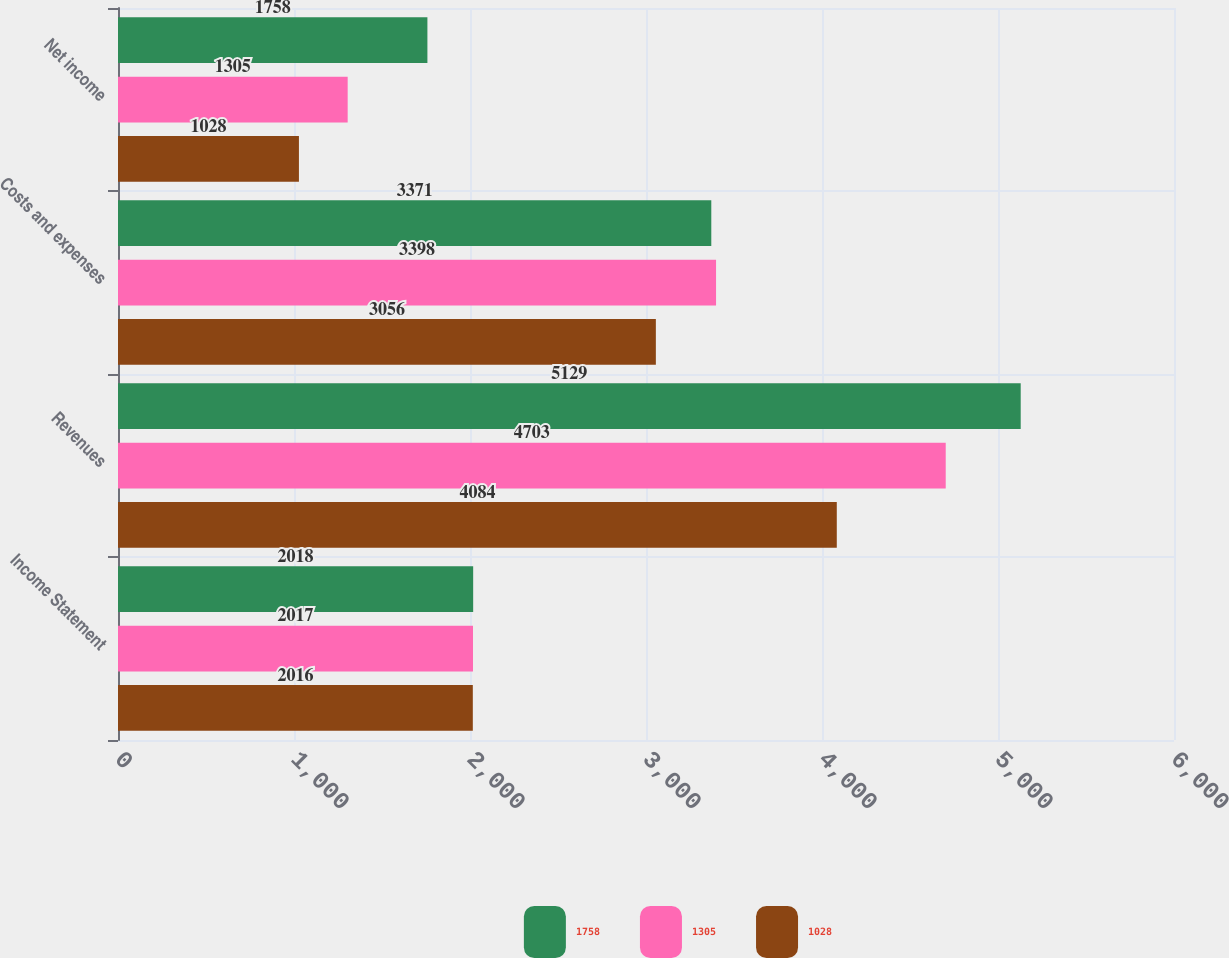<chart> <loc_0><loc_0><loc_500><loc_500><stacked_bar_chart><ecel><fcel>Income Statement<fcel>Revenues<fcel>Costs and expenses<fcel>Net income<nl><fcel>1758<fcel>2018<fcel>5129<fcel>3371<fcel>1758<nl><fcel>1305<fcel>2017<fcel>4703<fcel>3398<fcel>1305<nl><fcel>1028<fcel>2016<fcel>4084<fcel>3056<fcel>1028<nl></chart> 